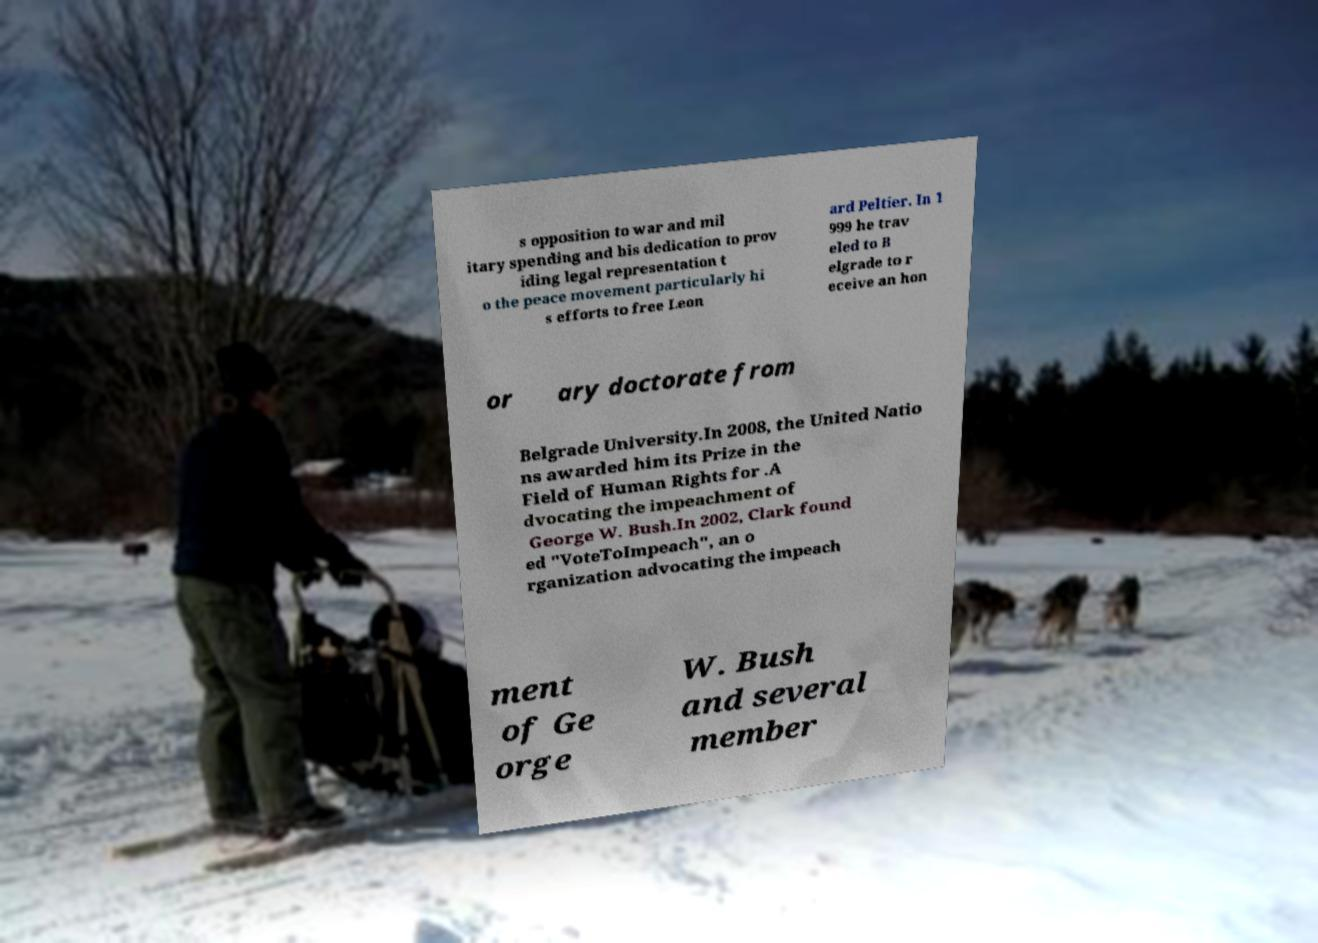What messages or text are displayed in this image? I need them in a readable, typed format. s opposition to war and mil itary spending and his dedication to prov iding legal representation t o the peace movement particularly hi s efforts to free Leon ard Peltier. In 1 999 he trav eled to B elgrade to r eceive an hon or ary doctorate from Belgrade University.In 2008, the United Natio ns awarded him its Prize in the Field of Human Rights for .A dvocating the impeachment of George W. Bush.In 2002, Clark found ed "VoteToImpeach", an o rganization advocating the impeach ment of Ge orge W. Bush and several member 